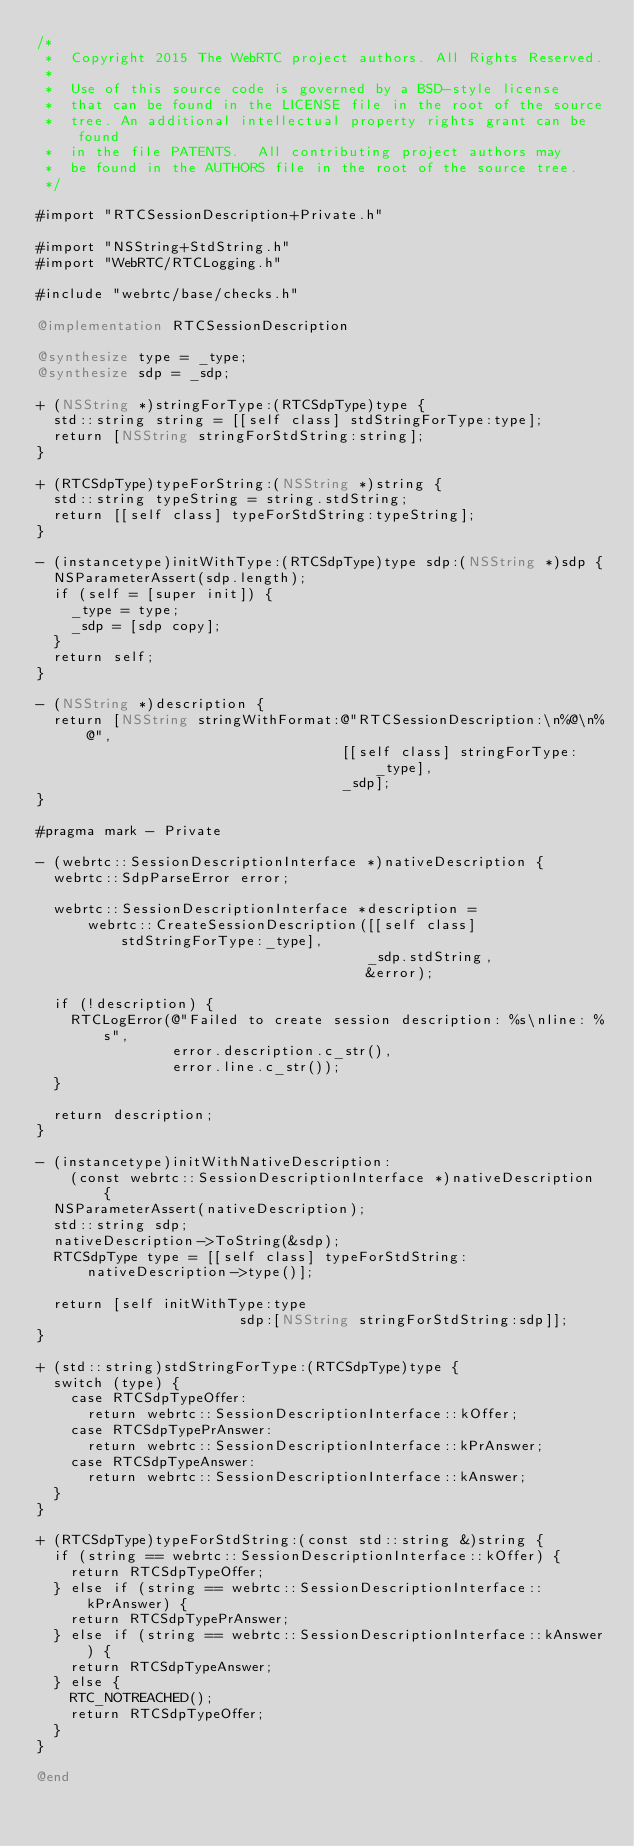Convert code to text. <code><loc_0><loc_0><loc_500><loc_500><_ObjectiveC_>/*
 *  Copyright 2015 The WebRTC project authors. All Rights Reserved.
 *
 *  Use of this source code is governed by a BSD-style license
 *  that can be found in the LICENSE file in the root of the source
 *  tree. An additional intellectual property rights grant can be found
 *  in the file PATENTS.  All contributing project authors may
 *  be found in the AUTHORS file in the root of the source tree.
 */

#import "RTCSessionDescription+Private.h"

#import "NSString+StdString.h"
#import "WebRTC/RTCLogging.h"

#include "webrtc/base/checks.h"

@implementation RTCSessionDescription

@synthesize type = _type;
@synthesize sdp = _sdp;

+ (NSString *)stringForType:(RTCSdpType)type {
  std::string string = [[self class] stdStringForType:type];
  return [NSString stringForStdString:string];
}

+ (RTCSdpType)typeForString:(NSString *)string {
  std::string typeString = string.stdString;
  return [[self class] typeForStdString:typeString];
}

- (instancetype)initWithType:(RTCSdpType)type sdp:(NSString *)sdp {
  NSParameterAssert(sdp.length);
  if (self = [super init]) {
    _type = type;
    _sdp = [sdp copy];
  }
  return self;
}

- (NSString *)description {
  return [NSString stringWithFormat:@"RTCSessionDescription:\n%@\n%@",
                                    [[self class] stringForType:_type],
                                    _sdp];
}

#pragma mark - Private

- (webrtc::SessionDescriptionInterface *)nativeDescription {
  webrtc::SdpParseError error;

  webrtc::SessionDescriptionInterface *description =
      webrtc::CreateSessionDescription([[self class] stdStringForType:_type],
                                       _sdp.stdString,
                                       &error);

  if (!description) {
    RTCLogError(@"Failed to create session description: %s\nline: %s",
                error.description.c_str(),
                error.line.c_str());
  }

  return description;
}

- (instancetype)initWithNativeDescription:
    (const webrtc::SessionDescriptionInterface *)nativeDescription {
  NSParameterAssert(nativeDescription);
  std::string sdp;
  nativeDescription->ToString(&sdp);
  RTCSdpType type = [[self class] typeForStdString:nativeDescription->type()];

  return [self initWithType:type
                        sdp:[NSString stringForStdString:sdp]];
}

+ (std::string)stdStringForType:(RTCSdpType)type {
  switch (type) {
    case RTCSdpTypeOffer:
      return webrtc::SessionDescriptionInterface::kOffer;
    case RTCSdpTypePrAnswer:
      return webrtc::SessionDescriptionInterface::kPrAnswer;
    case RTCSdpTypeAnswer:
      return webrtc::SessionDescriptionInterface::kAnswer;
  }
}

+ (RTCSdpType)typeForStdString:(const std::string &)string {
  if (string == webrtc::SessionDescriptionInterface::kOffer) {
    return RTCSdpTypeOffer;
  } else if (string == webrtc::SessionDescriptionInterface::kPrAnswer) {
    return RTCSdpTypePrAnswer;
  } else if (string == webrtc::SessionDescriptionInterface::kAnswer) {
    return RTCSdpTypeAnswer;
  } else {
    RTC_NOTREACHED();
    return RTCSdpTypeOffer;
  }
}

@end
</code> 